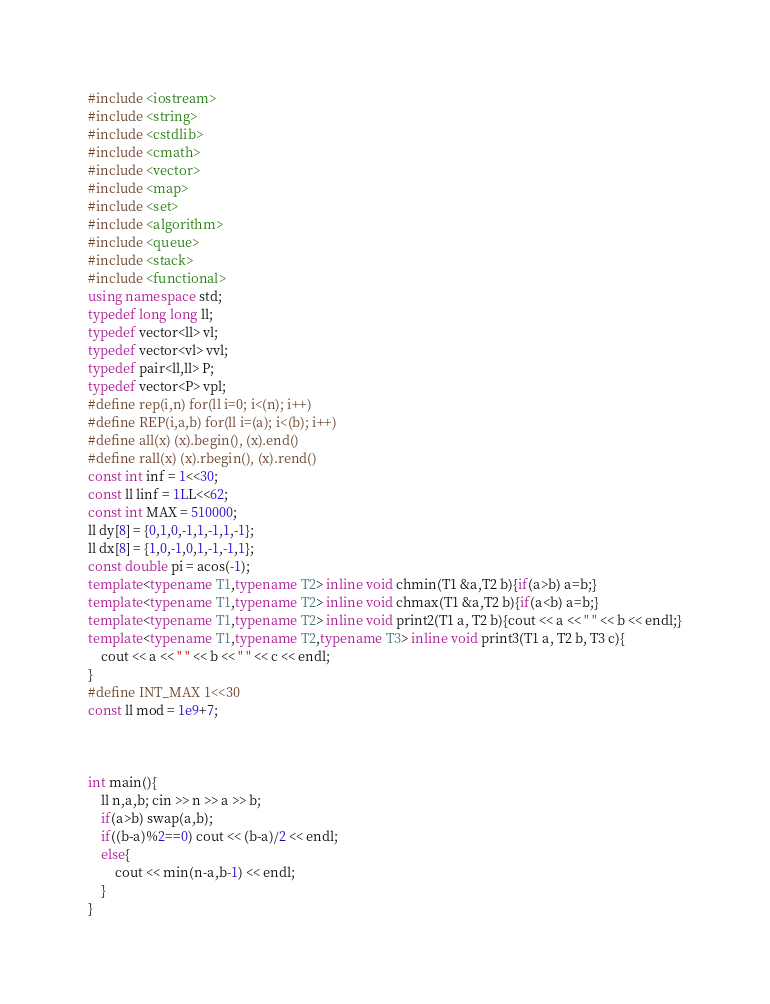<code> <loc_0><loc_0><loc_500><loc_500><_C++_>#include <iostream>
#include <string>
#include <cstdlib>
#include <cmath>
#include <vector>
#include <map>
#include <set>
#include <algorithm>
#include <queue>
#include <stack>
#include <functional>
using namespace std;
typedef long long ll;
typedef vector<ll> vl;
typedef vector<vl> vvl;
typedef pair<ll,ll> P;
typedef vector<P> vpl;
#define rep(i,n) for(ll i=0; i<(n); i++)
#define REP(i,a,b) for(ll i=(a); i<(b); i++)
#define all(x) (x).begin(), (x).end()
#define rall(x) (x).rbegin(), (x).rend()
const int inf = 1<<30;
const ll linf = 1LL<<62;
const int MAX = 510000;
ll dy[8] = {0,1,0,-1,1,-1,1,-1};
ll dx[8] = {1,0,-1,0,1,-1,-1,1};
const double pi = acos(-1);
template<typename T1,typename T2> inline void chmin(T1 &a,T2 b){if(a>b) a=b;}
template<typename T1,typename T2> inline void chmax(T1 &a,T2 b){if(a<b) a=b;}
template<typename T1,typename T2> inline void print2(T1 a, T2 b){cout << a << " " << b << endl;}
template<typename T1,typename T2,typename T3> inline void print3(T1 a, T2 b, T3 c){
	cout << a << " " << b << " " << c << endl;
}
#define INT_MAX 1<<30
const ll mod = 1e9+7;



int main(){
	ll n,a,b; cin >> n >> a >> b;
	if(a>b) swap(a,b);
	if((b-a)%2==0) cout << (b-a)/2 << endl;
	else{
		cout << min(n-a,b-1) << endl;
	}
}
</code> 